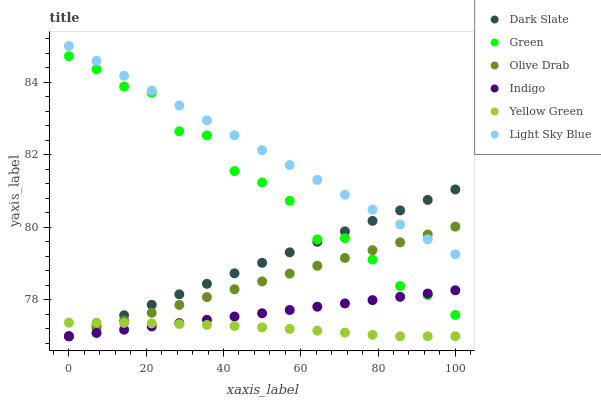Does Yellow Green have the minimum area under the curve?
Answer yes or no. Yes. Does Light Sky Blue have the maximum area under the curve?
Answer yes or no. Yes. Does Dark Slate have the minimum area under the curve?
Answer yes or no. No. Does Dark Slate have the maximum area under the curve?
Answer yes or no. No. Is Olive Drab the smoothest?
Answer yes or no. Yes. Is Green the roughest?
Answer yes or no. Yes. Is Yellow Green the smoothest?
Answer yes or no. No. Is Yellow Green the roughest?
Answer yes or no. No. Does Indigo have the lowest value?
Answer yes or no. Yes. Does Light Sky Blue have the lowest value?
Answer yes or no. No. Does Light Sky Blue have the highest value?
Answer yes or no. Yes. Does Dark Slate have the highest value?
Answer yes or no. No. Is Yellow Green less than Light Sky Blue?
Answer yes or no. Yes. Is Light Sky Blue greater than Indigo?
Answer yes or no. Yes. Does Indigo intersect Dark Slate?
Answer yes or no. Yes. Is Indigo less than Dark Slate?
Answer yes or no. No. Is Indigo greater than Dark Slate?
Answer yes or no. No. Does Yellow Green intersect Light Sky Blue?
Answer yes or no. No. 